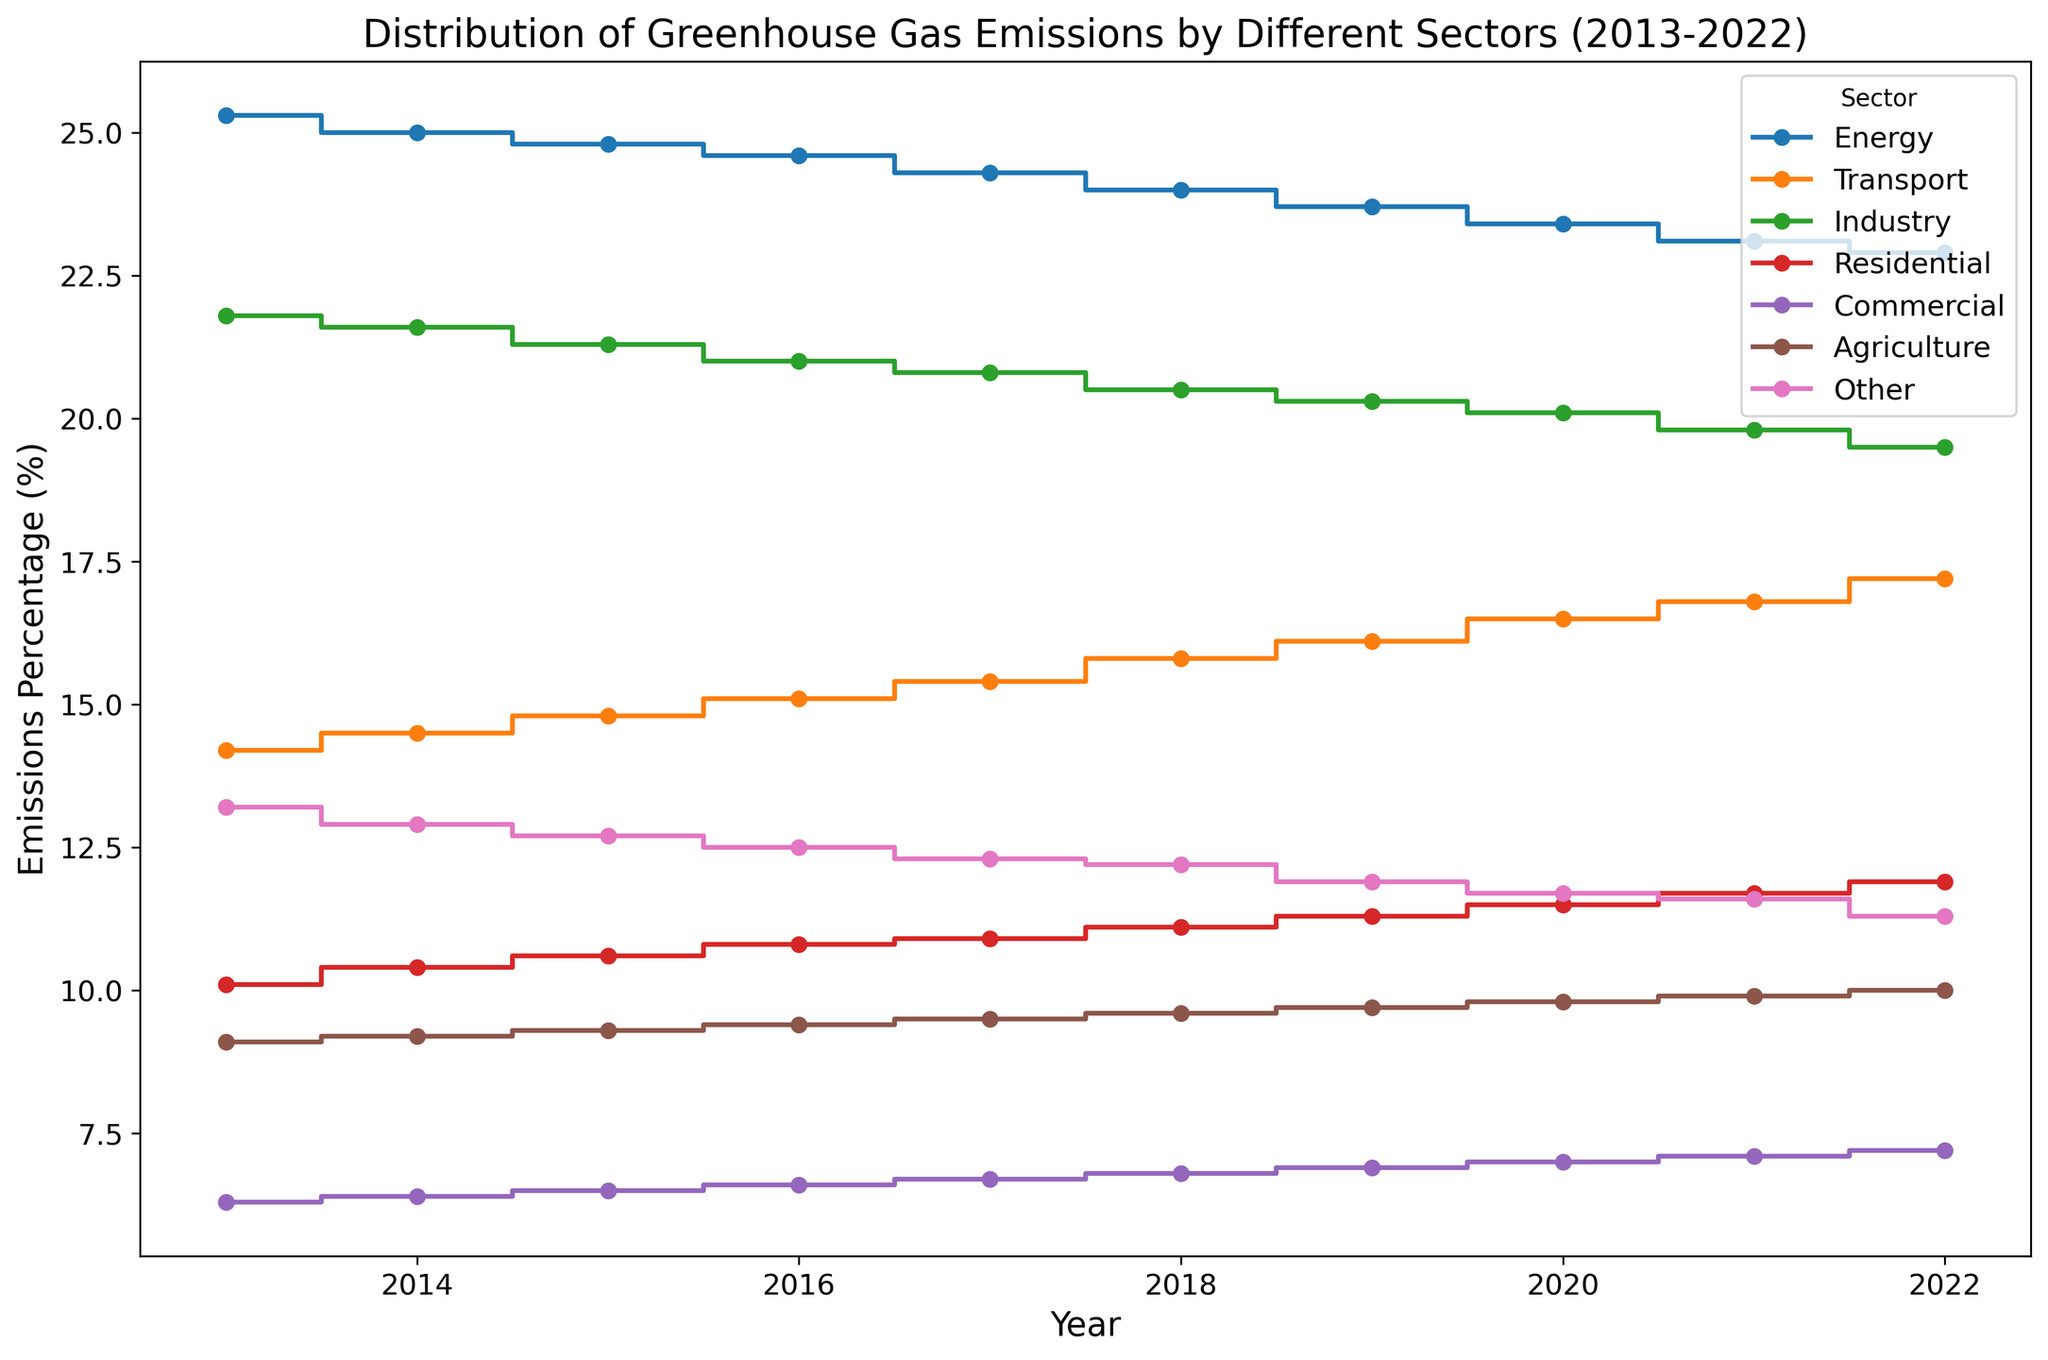What is the overall trend of emissions in the Energy sector from 2013 to 2022? To determine the overall trend in the Energy sector, we need to observe the values plotted for each year from 2013 to 2022. The emissions percentage in the Energy sector decreases from 25.3% in 2013 to 22.9% in 2022, indicating a downward trend.
Answer: Downward trend In which year did the Residential sector have the highest emissions percentage, and what was the value? By looking at the plotted points for the Residential sector, the highest point corresponds to the year 2022 with an emissions percentage of 11.9%.
Answer: 2022, 11.9% Which sector had the smallest decrease in emissions over the past decade? To solve this, calculate the reduction for each sector by subtracting the value in 2022 from the value in 2013. The Other sector shows the smallest decrease in emissions from 13.2% in 2013 to 11.3% in 2022.
Answer: Other sector What is the average emissions percentage for the Transport sector across the years displayed? To find the average emissions percentage for the Transport sector, sum the values from 2013 to 2022 and divide by the number of years. The sum is (14.2 + 14.5 + 14.8 + 15.1 + 15.4 + 15.8 + 16.1 + 16.5 + 16.8 + 17.2) = 156.4. The average is 156.4 / 10 = 15.64%.
Answer: 15.64% By how much did the emissions percentage in the Industry sector decrease from 2013 to 2022? Subtract the emissions percentage in 2022 from the value in 2013. The decrease in the Industry sector is 21.8% - 19.5% = 2.3%.
Answer: 2.3% Which sector shows an increase in emissions in every year shown in the figure? By checking the plotted lines for each sector, the Transport sector shows a continuous increase in emissions from 2013 to 2022.
Answer: Transport sector In 2017, what is the total percentage of emissions from the Energy, Industry, and Residential sectors combined? Add the emissions percentages of these three sectors for the year 2017: Energy (24.3%), Industry (20.8%), and Residential (10.9%). The total is 24.3 + 20.8 + 10.9 = 56%.
Answer: 56% Which year had the lowest emissions percentage in the Commercial sector and what was the value? Locate the lowest point on the line representing the Commercial sector's emissions. The year 2013 has the lowest emissions percentage at 6.3%.
Answer: 2013, 6.3% Between 2018 and 2022, which sector had the greatest increase in emissions percentage and what was the value change? Calculate the change for each sector between 2018 and 2022 and determine the greatest increase. The Agriculture sector increased from 9.6% in 2018 to 10.0% in 2022, resulting in the largest increase of 0.4%.
Answer: Agriculture sector, 0.4% When did the Agriculture sector first reach an emissions percentage of 9.7%, and how long did it stay at or above this level? Check the point where the Agriculture sector first reaches 9.7%. It reached this level in 2019 and stayed at or above this level through to 2022, which means it remained for 4 consecutive years.
Answer: 2019, 4 years 